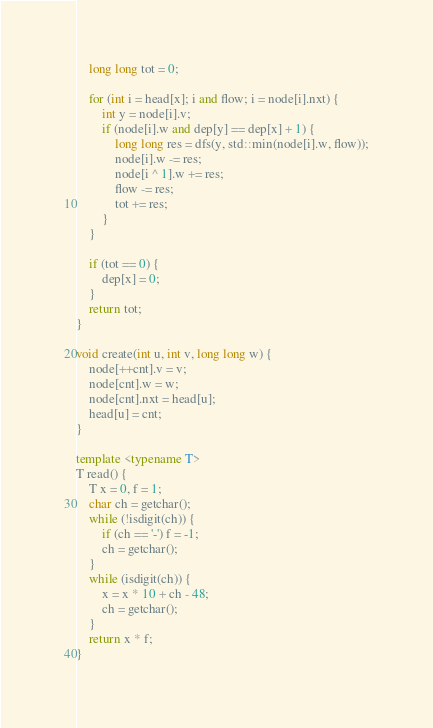Convert code to text. <code><loc_0><loc_0><loc_500><loc_500><_C++_>    long long tot = 0;

    for (int i = head[x]; i and flow; i = node[i].nxt) {
        int y = node[i].v;
        if (node[i].w and dep[y] == dep[x] + 1) {
            long long res = dfs(y, std::min(node[i].w, flow));
            node[i].w -= res;
            node[i ^ 1].w += res;
            flow -= res;
            tot += res;
        }
    }

    if (tot == 0) {
        dep[x] = 0;
    }
    return tot;
}

void create(int u, int v, long long w) {
    node[++cnt].v = v;
    node[cnt].w = w;
    node[cnt].nxt = head[u];
    head[u] = cnt;
}

template <typename T>
T read() {
    T x = 0, f = 1;
    char ch = getchar();
    while (!isdigit(ch)) {
        if (ch == '-') f = -1;
        ch = getchar();
    }
    while (isdigit(ch)) {
        x = x * 10 + ch - 48;
        ch = getchar();
    }
    return x * f;
}</code> 